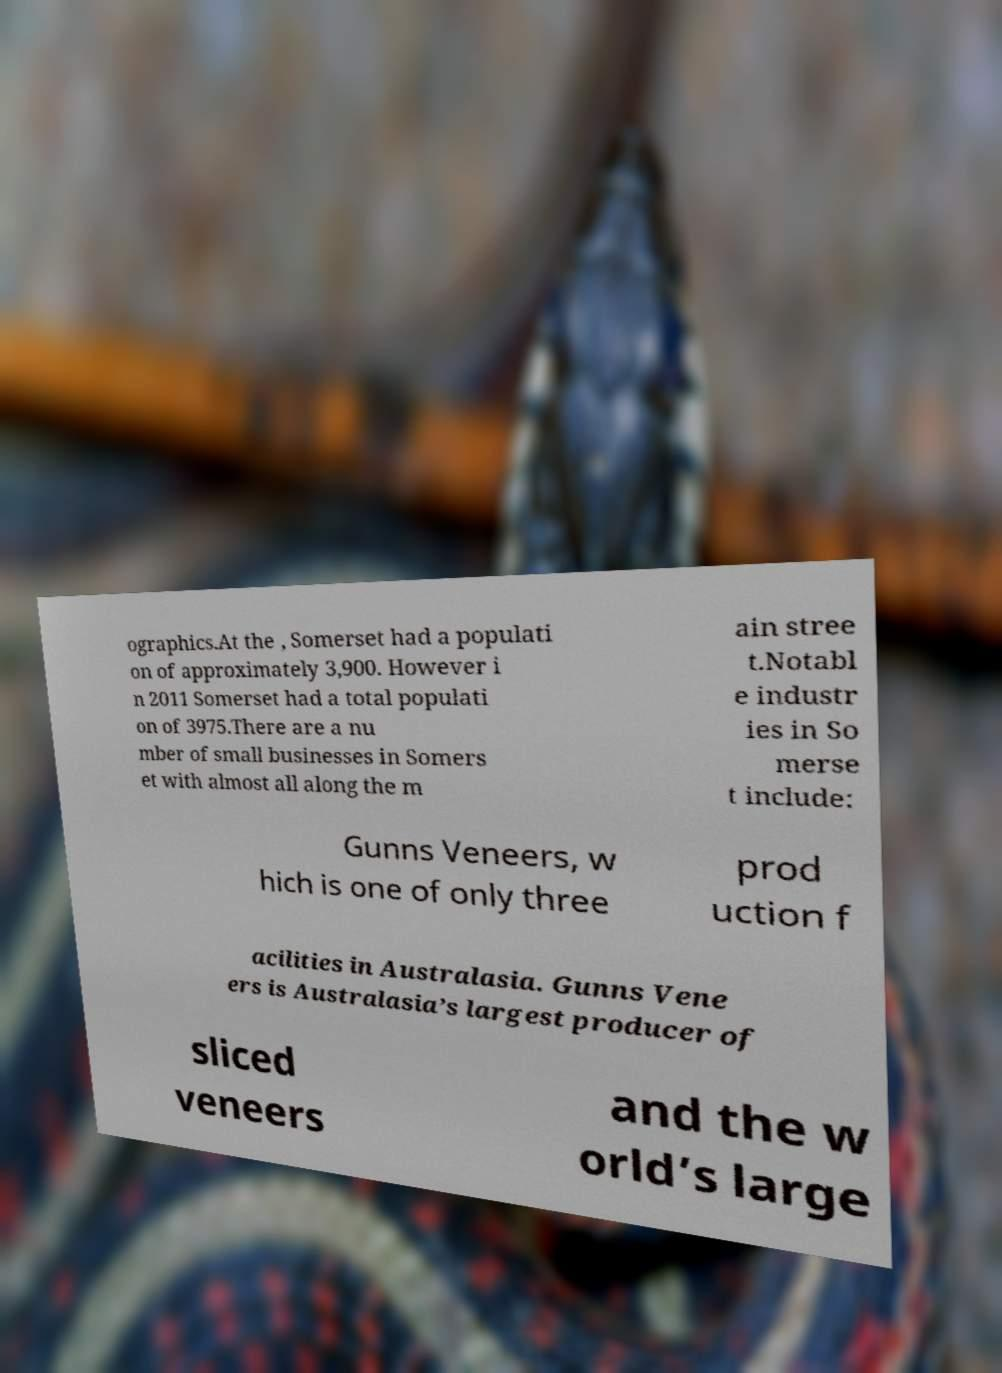What messages or text are displayed in this image? I need them in a readable, typed format. ographics.At the , Somerset had a populati on of approximately 3,900. However i n 2011 Somerset had a total populati on of 3975.There are a nu mber of small businesses in Somers et with almost all along the m ain stree t.Notabl e industr ies in So merse t include: Gunns Veneers, w hich is one of only three prod uction f acilities in Australasia. Gunns Vene ers is Australasia’s largest producer of sliced veneers and the w orld’s large 